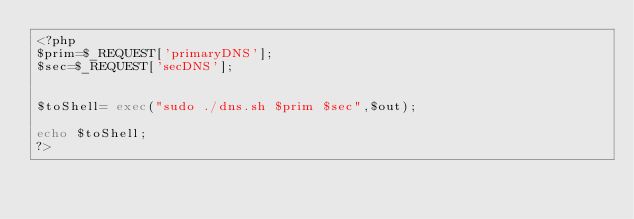<code> <loc_0><loc_0><loc_500><loc_500><_PHP_><?php
$prim=$_REQUEST['primaryDNS'];
$sec=$_REQUEST['secDNS'];


$toShell= exec("sudo ./dns.sh $prim $sec",$out);

echo $toShell;
?>
</code> 